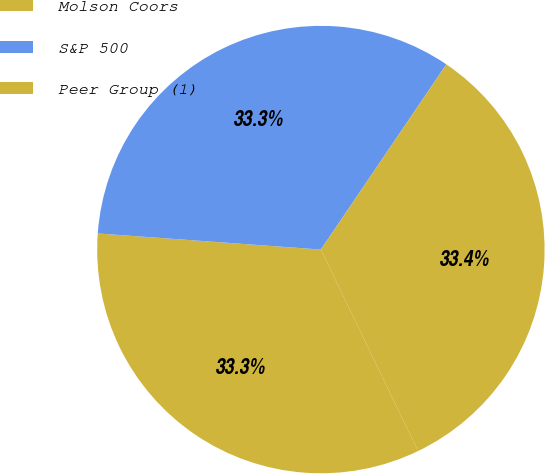Convert chart. <chart><loc_0><loc_0><loc_500><loc_500><pie_chart><fcel>Molson Coors<fcel>S&P 500<fcel>Peer Group (1)<nl><fcel>33.3%<fcel>33.33%<fcel>33.37%<nl></chart> 